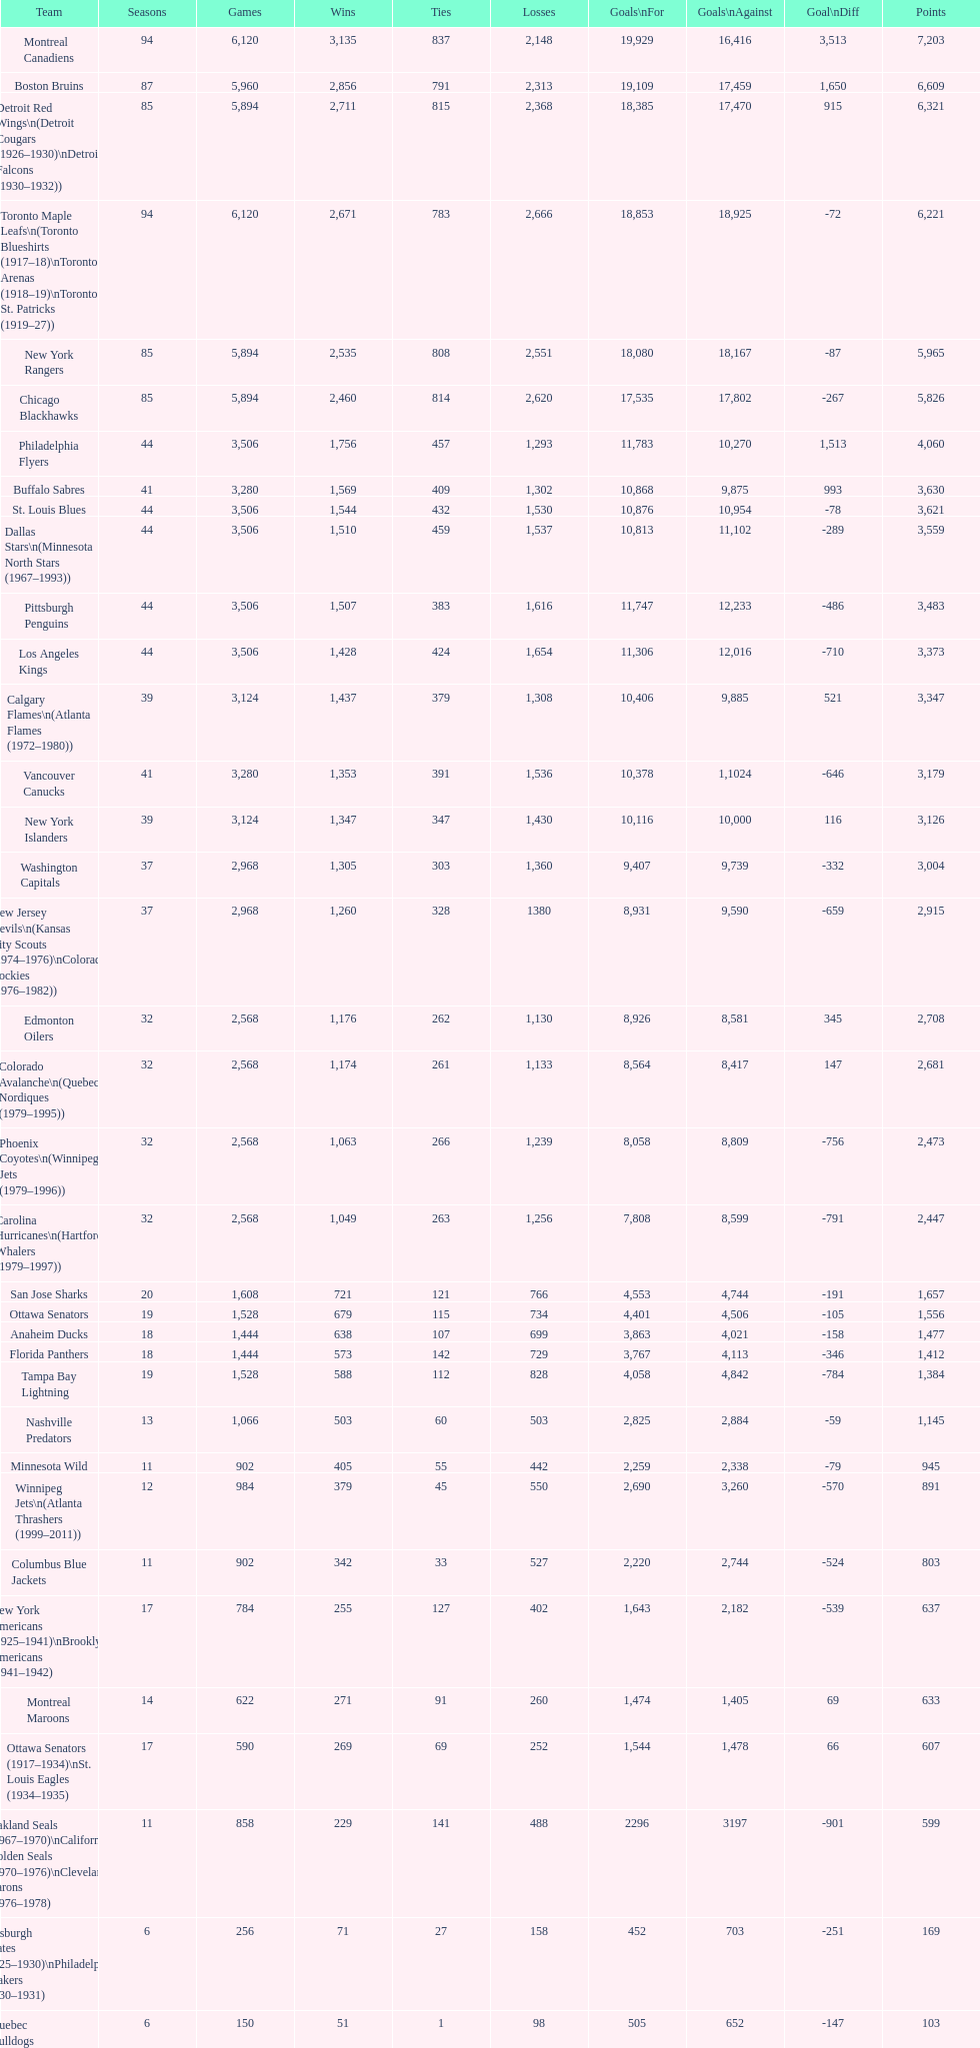Who holds the highest position on the list? Montreal Canadiens. 